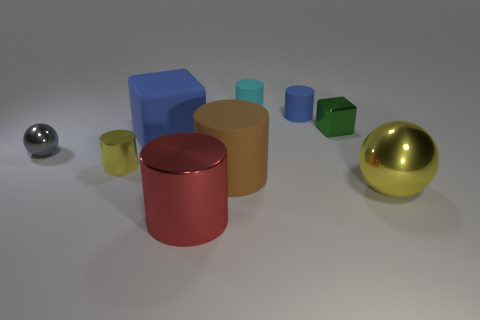Are there any other things that are the same shape as the small blue thing?
Offer a terse response. Yes. Do the large rubber object behind the big rubber cylinder and the matte cylinder right of the tiny cyan object have the same color?
Keep it short and to the point. Yes. How many shiny objects are big blue blocks or brown cylinders?
Give a very brief answer. 0. What is the shape of the yellow shiny object to the left of the cube that is in front of the green thing?
Keep it short and to the point. Cylinder. Are the block on the left side of the shiny block and the big cylinder that is on the right side of the red cylinder made of the same material?
Offer a very short reply. Yes. There is a metal ball on the left side of the cyan cylinder; how many blocks are on the left side of it?
Your answer should be compact. 0. Do the metallic object behind the tiny metallic ball and the blue object that is left of the red shiny cylinder have the same shape?
Your response must be concise. Yes. There is a shiny thing that is both behind the large brown thing and right of the big rubber block; what size is it?
Your answer should be compact. Small. What color is the other tiny matte object that is the same shape as the small blue object?
Ensure brevity in your answer.  Cyan. What color is the large matte thing behind the big cylinder to the right of the red cylinder?
Offer a terse response. Blue. 